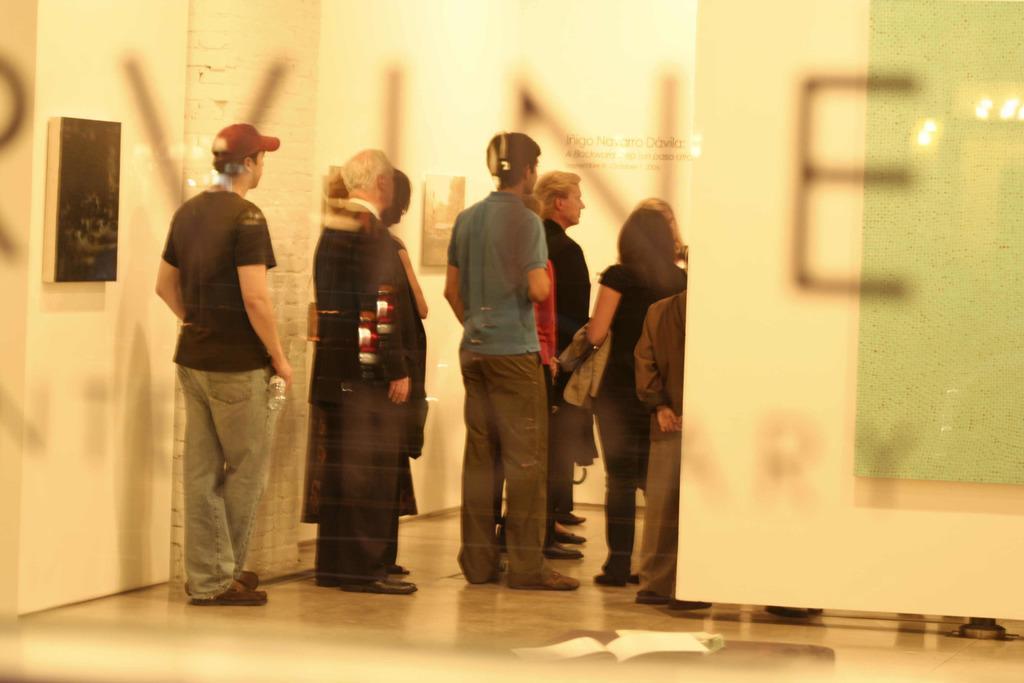Please provide a concise description of this image. This is a glass door and there is a text written on it to the other side. Through the glass door we can see few persons standing on the floor,frames and a name board on the wall. 